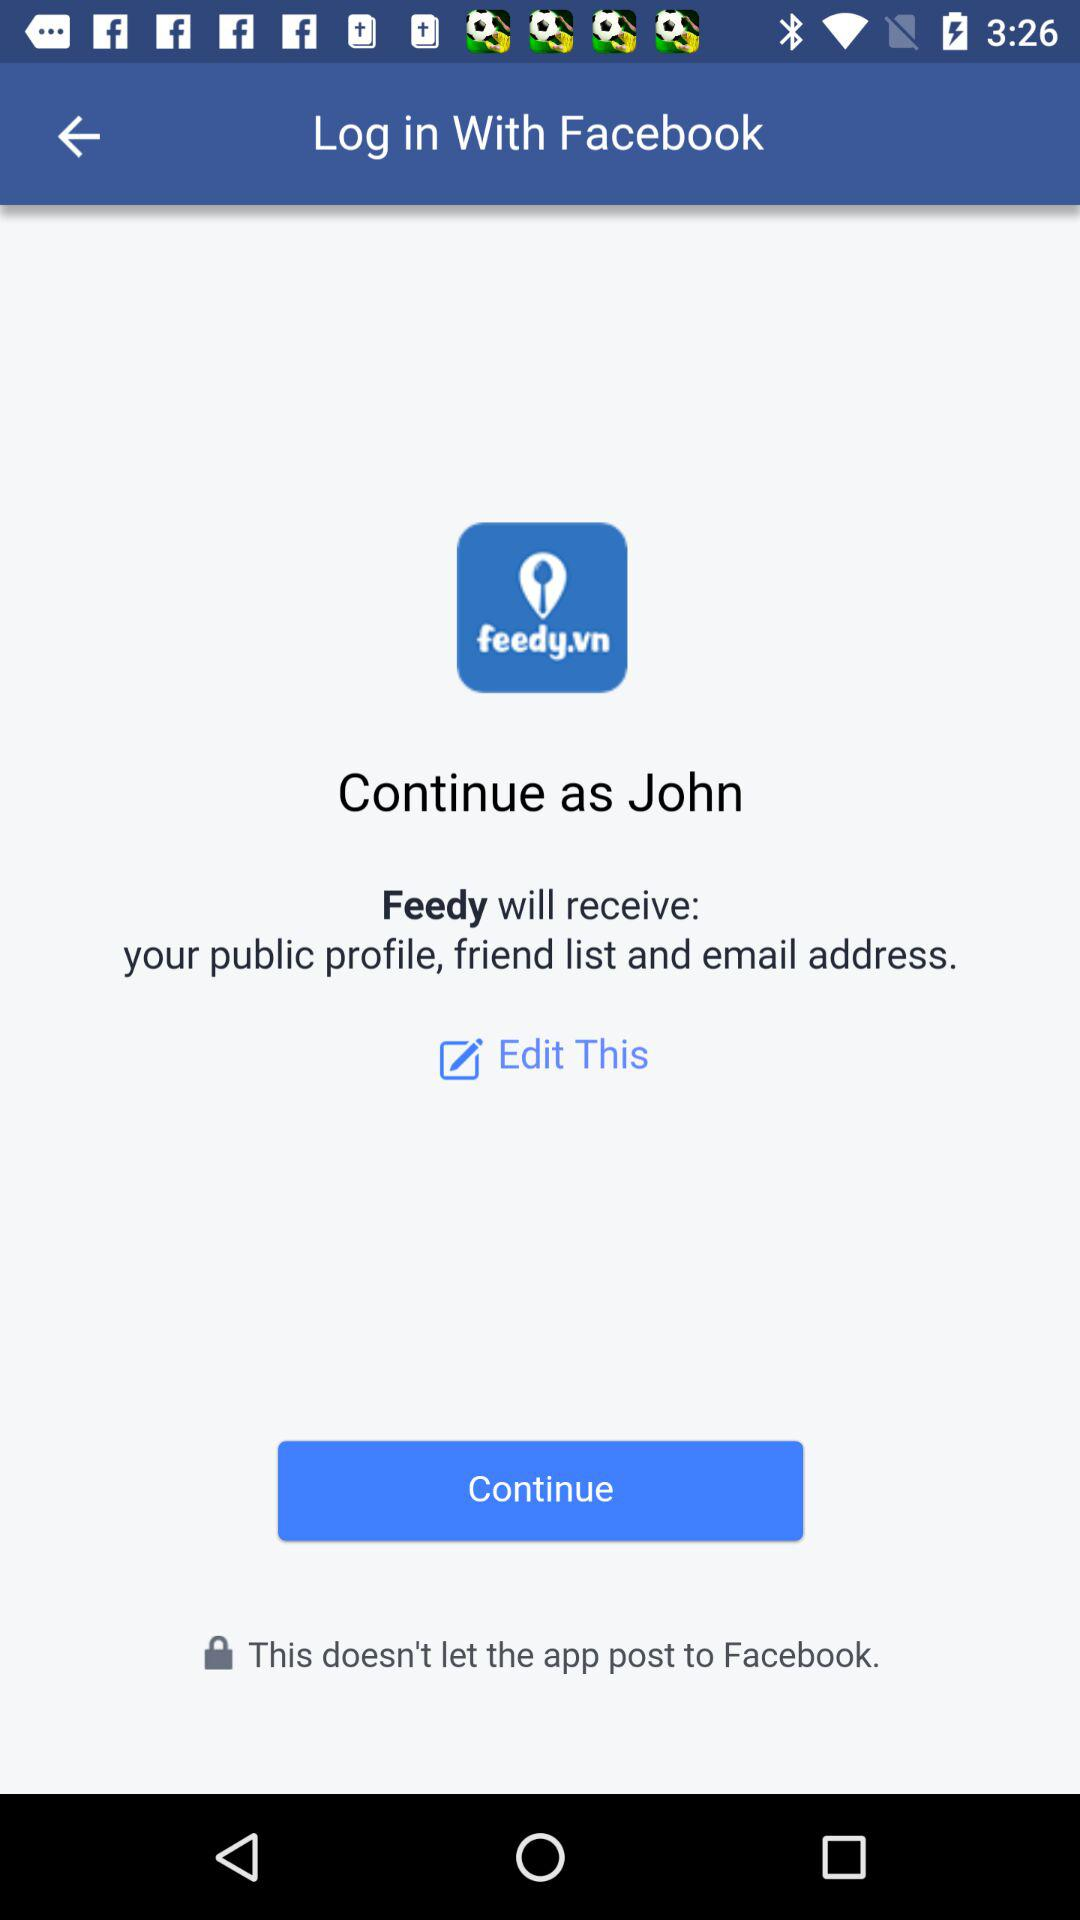What is the name of the user? The name of the user is John. 